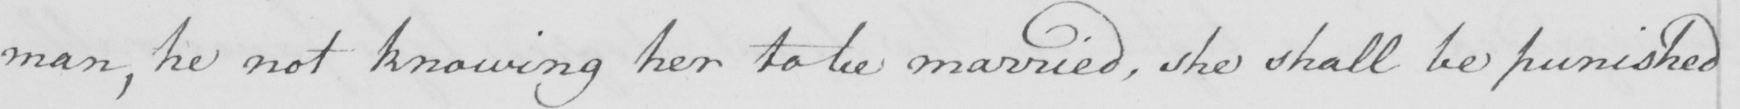What text is written in this handwritten line? man , he not knowing her to be married , she shall be punished 